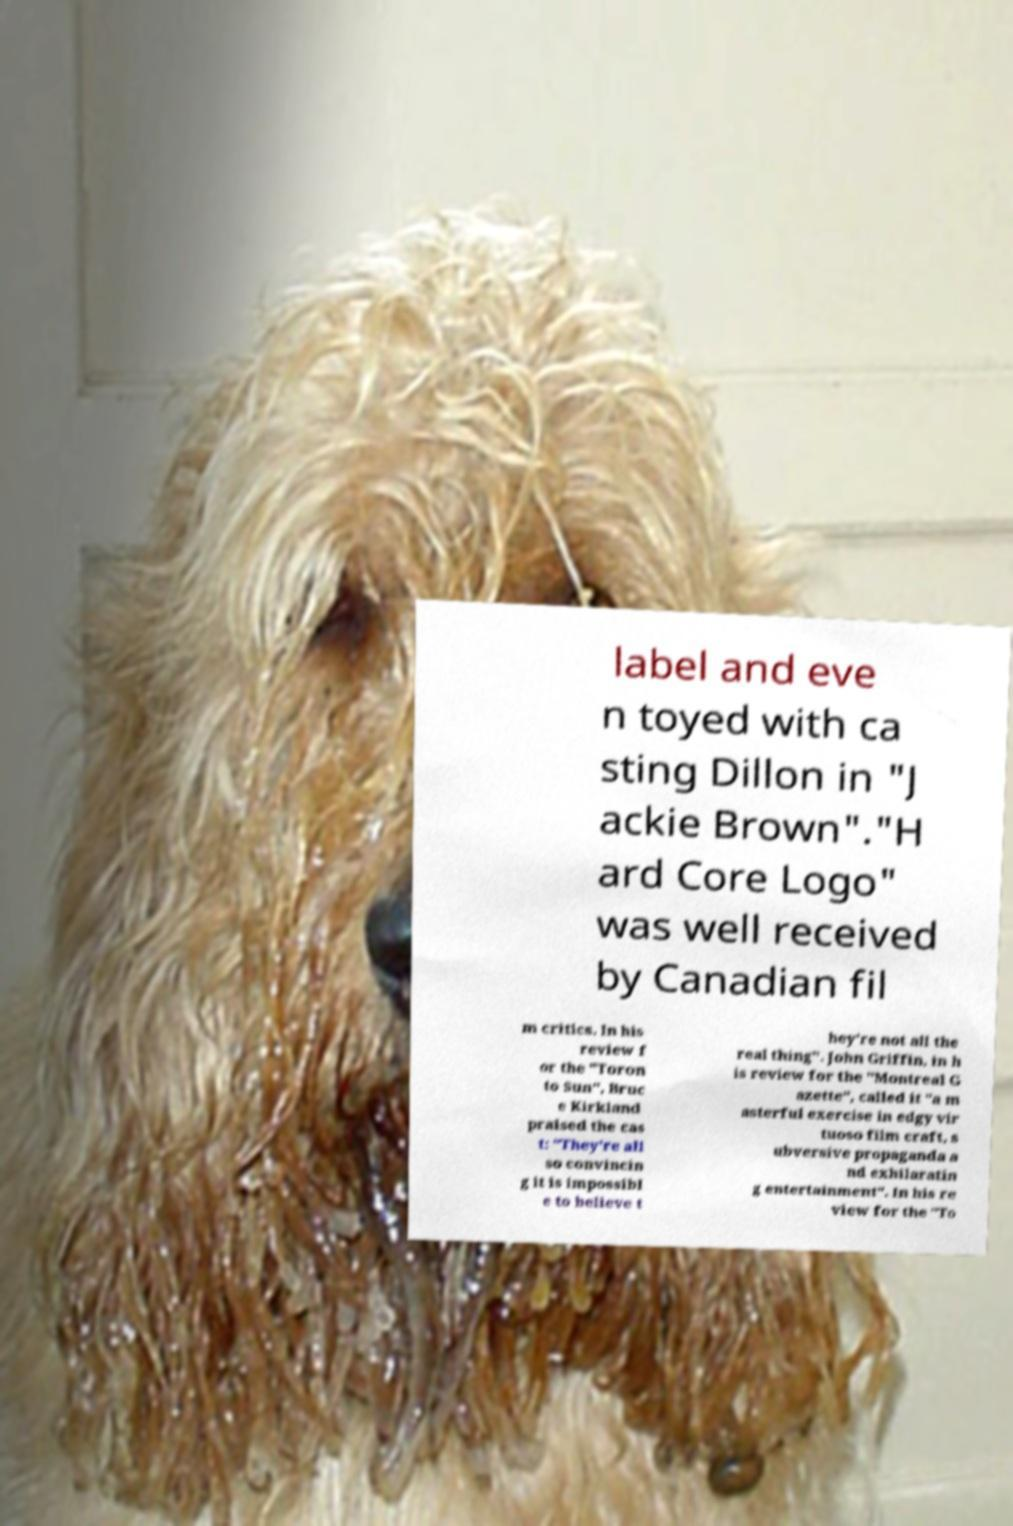Can you accurately transcribe the text from the provided image for me? label and eve n toyed with ca sting Dillon in "J ackie Brown"."H ard Core Logo" was well received by Canadian fil m critics. In his review f or the "Toron to Sun", Bruc e Kirkland praised the cas t: "They're all so convincin g it is impossibl e to believe t hey're not all the real thing". John Griffin, in h is review for the "Montreal G azette", called it "a m asterful exercise in edgy vir tuoso film craft, s ubversive propaganda a nd exhilaratin g entertainment". In his re view for the "To 